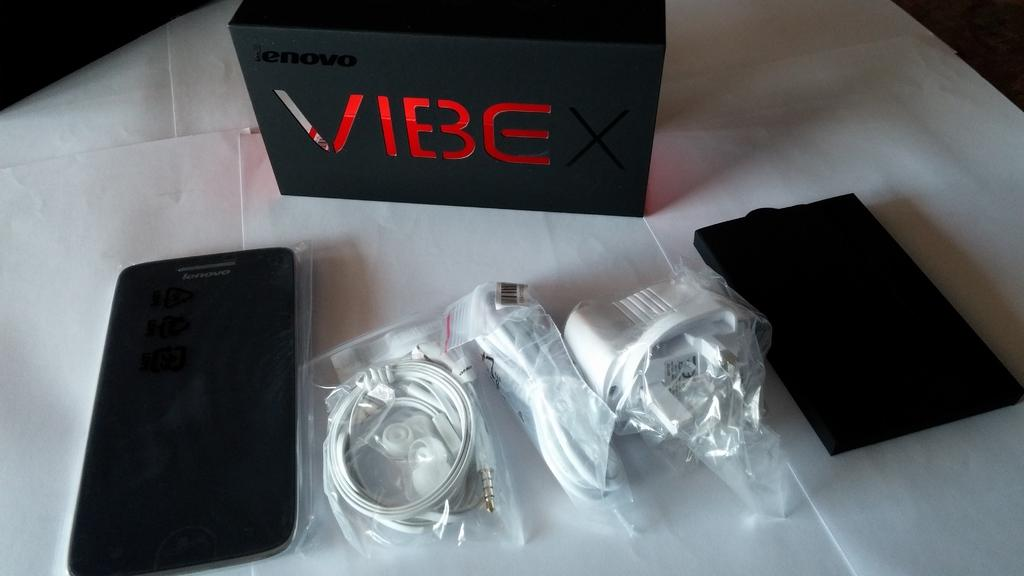<image>
Present a compact description of the photo's key features. Black box for a Lenovo Vibe and the products placed in front. 